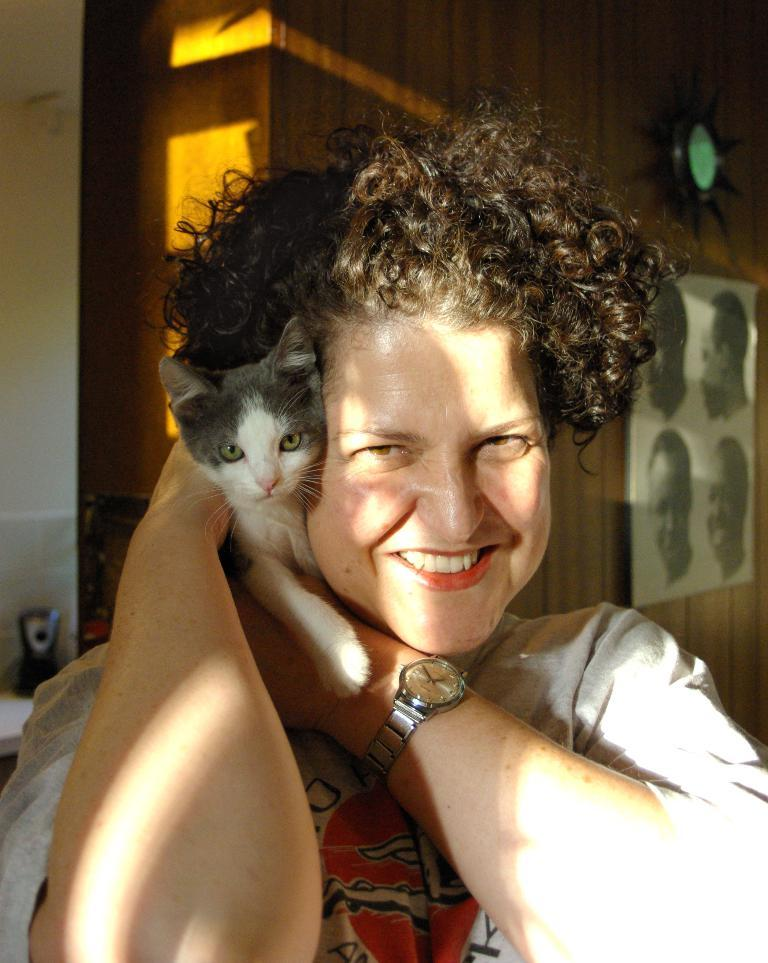What is the woman in the image holding? The woman is holding a cat. What is the woman wearing on her wrist? The woman is wearing a watch. What expression does the woman have in the image? The woman is smiling. What can be seen in the background of the image? There is a wooden cupboard in the background. What is on the wooden cupboard? There is a frame on the wooden cupboard. What type of tree can be seen in the image? There is no tree present in the image. How does the woman zip up her sweater in the image? The woman is not shown zipping up a sweater in the image. 